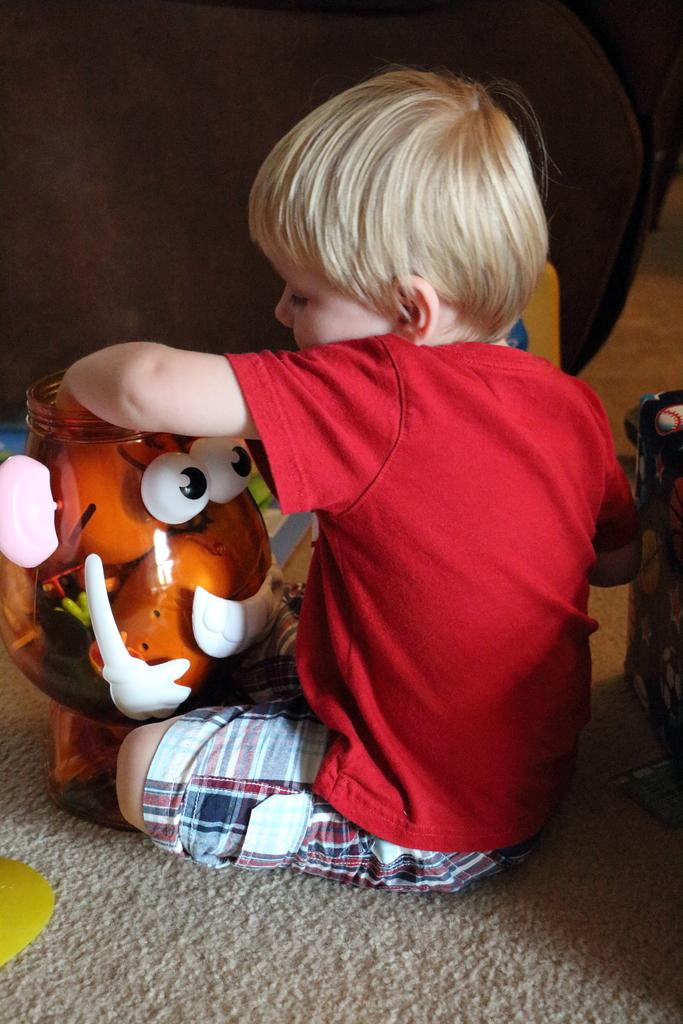Who is the main subject in the image? There is a boy in the image. What is the boy doing in the image? The boy is playing with toys. What is the boy wearing in the image? The boy is wearing a red t-shirt and a checkered shirt. What is at the bottom of the image? There is a mat at the bottom of the image. What type of brass instrument is the boy playing with in the image? There is no brass instrument present in the image; the boy is playing with toys. Can you see a duck in the image? There is no duck present in the image. 